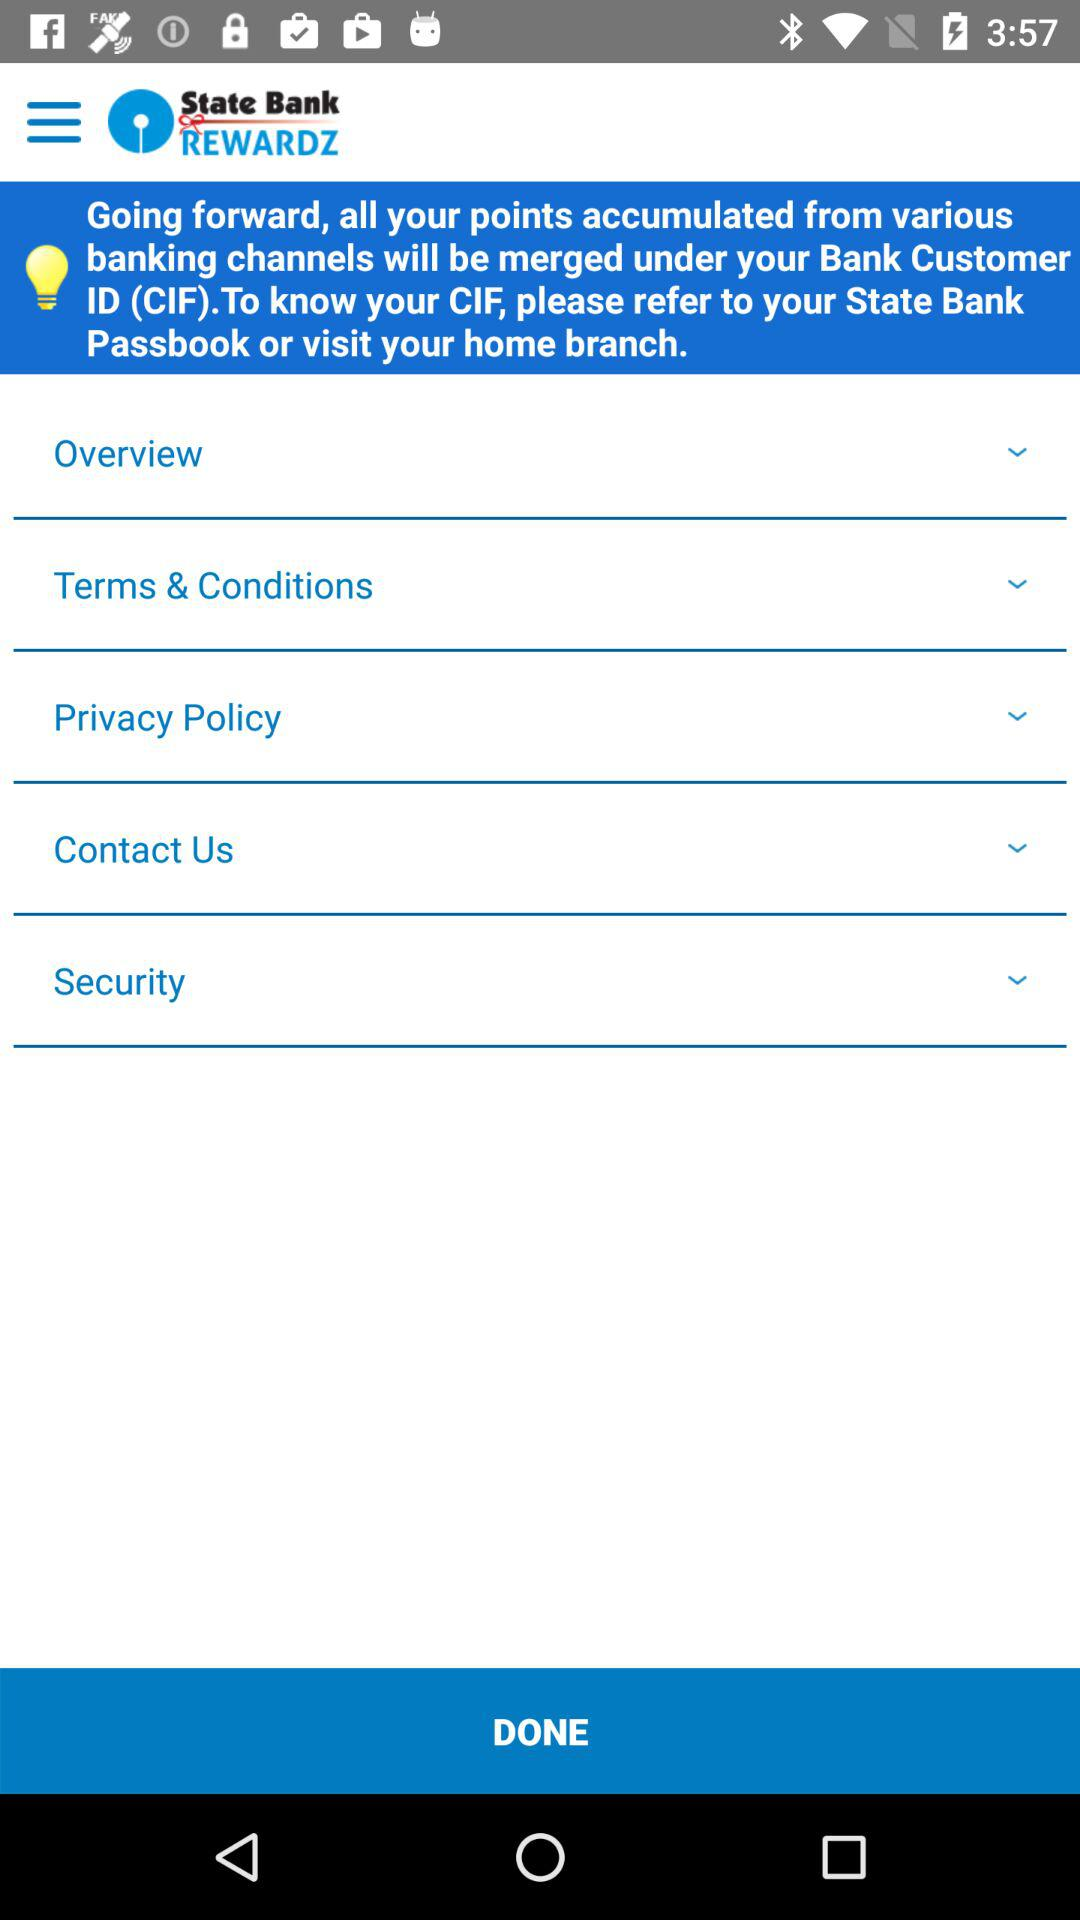What is the application name? The application name is "State Bank REWARDZ". 